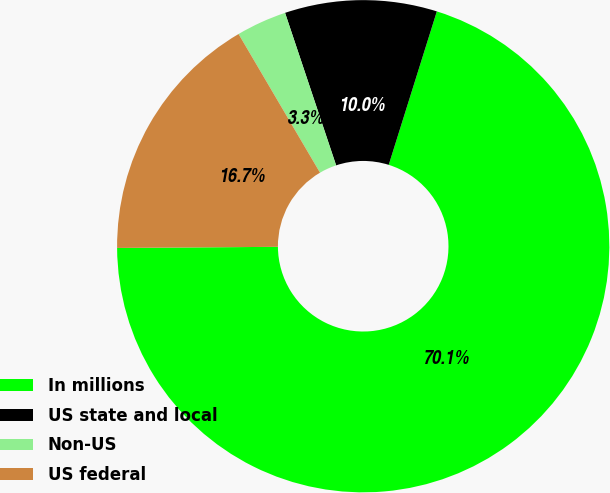Convert chart to OTSL. <chart><loc_0><loc_0><loc_500><loc_500><pie_chart><fcel>In millions<fcel>US state and local<fcel>Non-US<fcel>US federal<nl><fcel>70.06%<fcel>9.98%<fcel>3.31%<fcel>16.66%<nl></chart> 